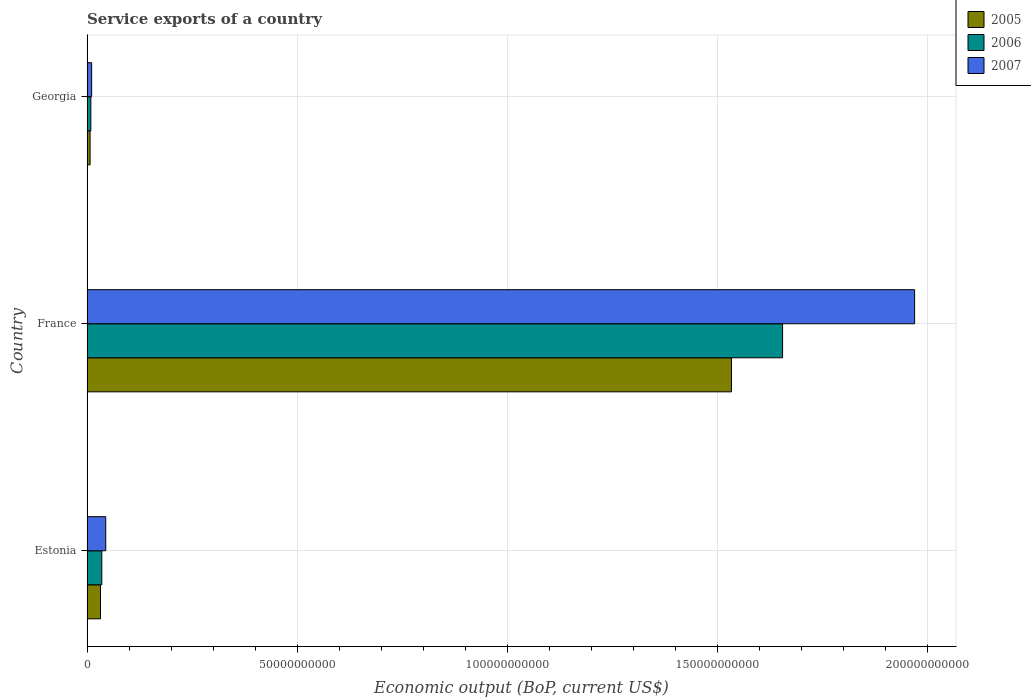How many groups of bars are there?
Offer a very short reply. 3. How many bars are there on the 1st tick from the top?
Provide a short and direct response. 3. How many bars are there on the 3rd tick from the bottom?
Offer a very short reply. 3. What is the label of the 1st group of bars from the top?
Provide a short and direct response. Georgia. In how many cases, is the number of bars for a given country not equal to the number of legend labels?
Keep it short and to the point. 0. What is the service exports in 2005 in Estonia?
Your response must be concise. 3.21e+09. Across all countries, what is the maximum service exports in 2006?
Your response must be concise. 1.65e+11. Across all countries, what is the minimum service exports in 2006?
Provide a short and direct response. 9.13e+08. In which country was the service exports in 2007 minimum?
Provide a succinct answer. Georgia. What is the total service exports in 2005 in the graph?
Your response must be concise. 1.57e+11. What is the difference between the service exports in 2005 in Estonia and that in Georgia?
Make the answer very short. 2.47e+09. What is the difference between the service exports in 2007 in Estonia and the service exports in 2005 in France?
Give a very brief answer. -1.49e+11. What is the average service exports in 2005 per country?
Ensure brevity in your answer.  5.24e+1. What is the difference between the service exports in 2007 and service exports in 2005 in France?
Provide a short and direct response. 4.36e+1. What is the ratio of the service exports in 2006 in France to that in Georgia?
Your answer should be compact. 181.09. Is the difference between the service exports in 2007 in France and Georgia greater than the difference between the service exports in 2005 in France and Georgia?
Keep it short and to the point. Yes. What is the difference between the highest and the second highest service exports in 2006?
Make the answer very short. 1.62e+11. What is the difference between the highest and the lowest service exports in 2007?
Offer a terse response. 1.96e+11. In how many countries, is the service exports in 2005 greater than the average service exports in 2005 taken over all countries?
Your answer should be compact. 1. What does the 2nd bar from the top in France represents?
Make the answer very short. 2006. What does the 1st bar from the bottom in Georgia represents?
Offer a terse response. 2005. How many bars are there?
Your answer should be compact. 9. How many countries are there in the graph?
Provide a short and direct response. 3. Are the values on the major ticks of X-axis written in scientific E-notation?
Give a very brief answer. No. Does the graph contain any zero values?
Your response must be concise. No. Does the graph contain grids?
Offer a very short reply. Yes. How many legend labels are there?
Your response must be concise. 3. How are the legend labels stacked?
Provide a succinct answer. Vertical. What is the title of the graph?
Ensure brevity in your answer.  Service exports of a country. What is the label or title of the X-axis?
Make the answer very short. Economic output (BoP, current US$). What is the Economic output (BoP, current US$) in 2005 in Estonia?
Provide a succinct answer. 3.21e+09. What is the Economic output (BoP, current US$) of 2006 in Estonia?
Provide a succinct answer. 3.52e+09. What is the Economic output (BoP, current US$) of 2007 in Estonia?
Offer a very short reply. 4.46e+09. What is the Economic output (BoP, current US$) in 2005 in France?
Provide a short and direct response. 1.53e+11. What is the Economic output (BoP, current US$) of 2006 in France?
Ensure brevity in your answer.  1.65e+11. What is the Economic output (BoP, current US$) in 2007 in France?
Keep it short and to the point. 1.97e+11. What is the Economic output (BoP, current US$) of 2005 in Georgia?
Make the answer very short. 7.38e+08. What is the Economic output (BoP, current US$) in 2006 in Georgia?
Make the answer very short. 9.13e+08. What is the Economic output (BoP, current US$) of 2007 in Georgia?
Provide a short and direct response. 1.11e+09. Across all countries, what is the maximum Economic output (BoP, current US$) in 2005?
Ensure brevity in your answer.  1.53e+11. Across all countries, what is the maximum Economic output (BoP, current US$) in 2006?
Your response must be concise. 1.65e+11. Across all countries, what is the maximum Economic output (BoP, current US$) in 2007?
Make the answer very short. 1.97e+11. Across all countries, what is the minimum Economic output (BoP, current US$) in 2005?
Offer a terse response. 7.38e+08. Across all countries, what is the minimum Economic output (BoP, current US$) of 2006?
Keep it short and to the point. 9.13e+08. Across all countries, what is the minimum Economic output (BoP, current US$) in 2007?
Your answer should be very brief. 1.11e+09. What is the total Economic output (BoP, current US$) in 2005 in the graph?
Keep it short and to the point. 1.57e+11. What is the total Economic output (BoP, current US$) of 2006 in the graph?
Your response must be concise. 1.70e+11. What is the total Economic output (BoP, current US$) of 2007 in the graph?
Give a very brief answer. 2.02e+11. What is the difference between the Economic output (BoP, current US$) of 2005 in Estonia and that in France?
Your answer should be compact. -1.50e+11. What is the difference between the Economic output (BoP, current US$) of 2006 in Estonia and that in France?
Give a very brief answer. -1.62e+11. What is the difference between the Economic output (BoP, current US$) in 2007 in Estonia and that in France?
Make the answer very short. -1.92e+11. What is the difference between the Economic output (BoP, current US$) in 2005 in Estonia and that in Georgia?
Keep it short and to the point. 2.47e+09. What is the difference between the Economic output (BoP, current US$) of 2006 in Estonia and that in Georgia?
Your answer should be very brief. 2.61e+09. What is the difference between the Economic output (BoP, current US$) in 2007 in Estonia and that in Georgia?
Make the answer very short. 3.35e+09. What is the difference between the Economic output (BoP, current US$) of 2005 in France and that in Georgia?
Keep it short and to the point. 1.53e+11. What is the difference between the Economic output (BoP, current US$) of 2006 in France and that in Georgia?
Make the answer very short. 1.65e+11. What is the difference between the Economic output (BoP, current US$) of 2007 in France and that in Georgia?
Offer a terse response. 1.96e+11. What is the difference between the Economic output (BoP, current US$) in 2005 in Estonia and the Economic output (BoP, current US$) in 2006 in France?
Offer a terse response. -1.62e+11. What is the difference between the Economic output (BoP, current US$) of 2005 in Estonia and the Economic output (BoP, current US$) of 2007 in France?
Provide a short and direct response. -1.94e+11. What is the difference between the Economic output (BoP, current US$) of 2006 in Estonia and the Economic output (BoP, current US$) of 2007 in France?
Your answer should be very brief. -1.93e+11. What is the difference between the Economic output (BoP, current US$) of 2005 in Estonia and the Economic output (BoP, current US$) of 2006 in Georgia?
Give a very brief answer. 2.30e+09. What is the difference between the Economic output (BoP, current US$) in 2005 in Estonia and the Economic output (BoP, current US$) in 2007 in Georgia?
Offer a terse response. 2.10e+09. What is the difference between the Economic output (BoP, current US$) of 2006 in Estonia and the Economic output (BoP, current US$) of 2007 in Georgia?
Ensure brevity in your answer.  2.42e+09. What is the difference between the Economic output (BoP, current US$) in 2005 in France and the Economic output (BoP, current US$) in 2006 in Georgia?
Provide a short and direct response. 1.52e+11. What is the difference between the Economic output (BoP, current US$) of 2005 in France and the Economic output (BoP, current US$) of 2007 in Georgia?
Keep it short and to the point. 1.52e+11. What is the difference between the Economic output (BoP, current US$) in 2006 in France and the Economic output (BoP, current US$) in 2007 in Georgia?
Your response must be concise. 1.64e+11. What is the average Economic output (BoP, current US$) in 2005 per country?
Provide a succinct answer. 5.24e+1. What is the average Economic output (BoP, current US$) of 2006 per country?
Your response must be concise. 5.66e+1. What is the average Economic output (BoP, current US$) in 2007 per country?
Provide a succinct answer. 6.75e+1. What is the difference between the Economic output (BoP, current US$) in 2005 and Economic output (BoP, current US$) in 2006 in Estonia?
Offer a terse response. -3.15e+08. What is the difference between the Economic output (BoP, current US$) in 2005 and Economic output (BoP, current US$) in 2007 in Estonia?
Provide a short and direct response. -1.25e+09. What is the difference between the Economic output (BoP, current US$) in 2006 and Economic output (BoP, current US$) in 2007 in Estonia?
Offer a terse response. -9.32e+08. What is the difference between the Economic output (BoP, current US$) of 2005 and Economic output (BoP, current US$) of 2006 in France?
Make the answer very short. -1.22e+1. What is the difference between the Economic output (BoP, current US$) in 2005 and Economic output (BoP, current US$) in 2007 in France?
Your answer should be compact. -4.36e+1. What is the difference between the Economic output (BoP, current US$) of 2006 and Economic output (BoP, current US$) of 2007 in France?
Offer a very short reply. -3.14e+1. What is the difference between the Economic output (BoP, current US$) in 2005 and Economic output (BoP, current US$) in 2006 in Georgia?
Make the answer very short. -1.76e+08. What is the difference between the Economic output (BoP, current US$) in 2005 and Economic output (BoP, current US$) in 2007 in Georgia?
Ensure brevity in your answer.  -3.69e+08. What is the difference between the Economic output (BoP, current US$) in 2006 and Economic output (BoP, current US$) in 2007 in Georgia?
Give a very brief answer. -1.94e+08. What is the ratio of the Economic output (BoP, current US$) of 2005 in Estonia to that in France?
Your response must be concise. 0.02. What is the ratio of the Economic output (BoP, current US$) of 2006 in Estonia to that in France?
Offer a terse response. 0.02. What is the ratio of the Economic output (BoP, current US$) in 2007 in Estonia to that in France?
Ensure brevity in your answer.  0.02. What is the ratio of the Economic output (BoP, current US$) of 2005 in Estonia to that in Georgia?
Give a very brief answer. 4.35. What is the ratio of the Economic output (BoP, current US$) in 2006 in Estonia to that in Georgia?
Provide a short and direct response. 3.86. What is the ratio of the Economic output (BoP, current US$) in 2007 in Estonia to that in Georgia?
Make the answer very short. 4.03. What is the ratio of the Economic output (BoP, current US$) of 2005 in France to that in Georgia?
Offer a very short reply. 207.71. What is the ratio of the Economic output (BoP, current US$) of 2006 in France to that in Georgia?
Your answer should be compact. 181.09. What is the ratio of the Economic output (BoP, current US$) of 2007 in France to that in Georgia?
Ensure brevity in your answer.  177.79. What is the difference between the highest and the second highest Economic output (BoP, current US$) of 2005?
Your answer should be very brief. 1.50e+11. What is the difference between the highest and the second highest Economic output (BoP, current US$) of 2006?
Your answer should be compact. 1.62e+11. What is the difference between the highest and the second highest Economic output (BoP, current US$) in 2007?
Offer a very short reply. 1.92e+11. What is the difference between the highest and the lowest Economic output (BoP, current US$) of 2005?
Keep it short and to the point. 1.53e+11. What is the difference between the highest and the lowest Economic output (BoP, current US$) in 2006?
Keep it short and to the point. 1.65e+11. What is the difference between the highest and the lowest Economic output (BoP, current US$) of 2007?
Ensure brevity in your answer.  1.96e+11. 